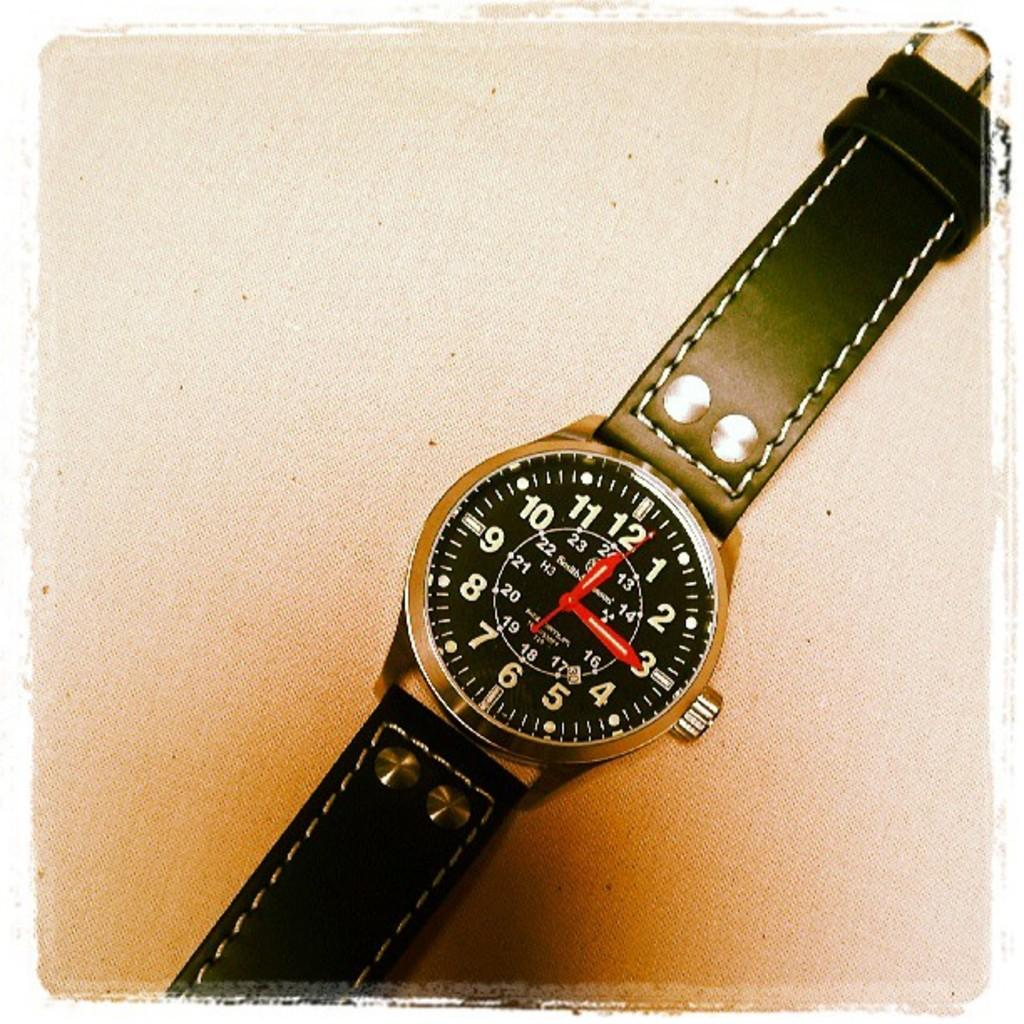<image>
Give a short and clear explanation of the subsequent image. a watch face with a black band and the time pointing at 12:15 